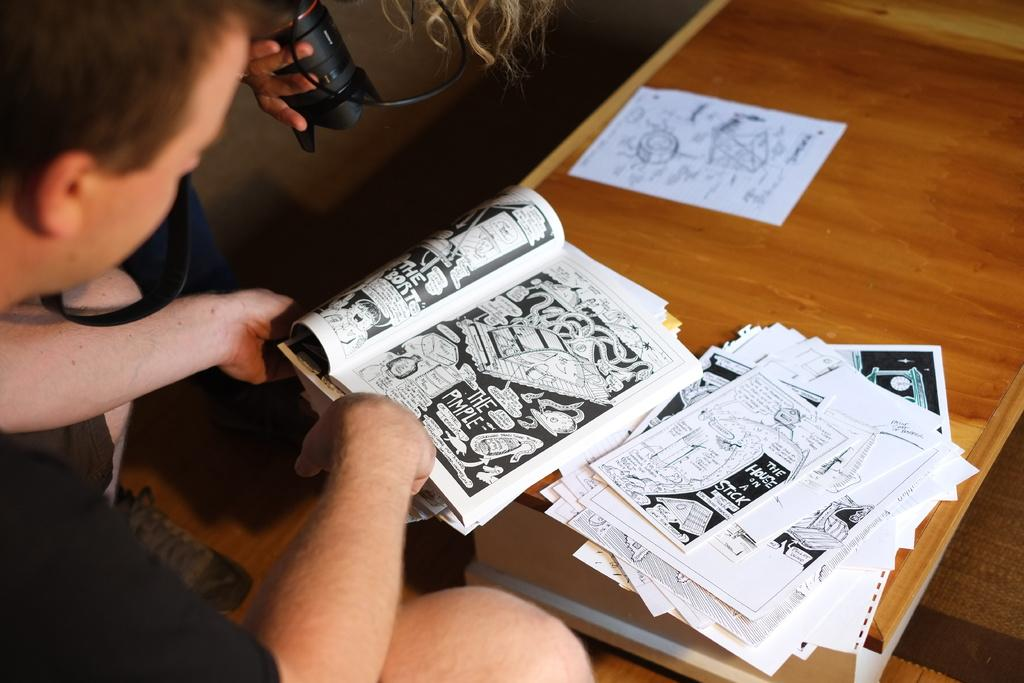What is the man in the image doing? The man is sitting beside a table in the image. What is on the table in the image? The table contains a book and some papers. What is the person standing on the floor holding? The person is holding a camera. What type of crime is being committed in the image? There is no indication of a crime being committed in the image. Can you recite a verse from the book in the image? We cannot recite a verse from the book in the image, as we do not have access to the contents of the book. 